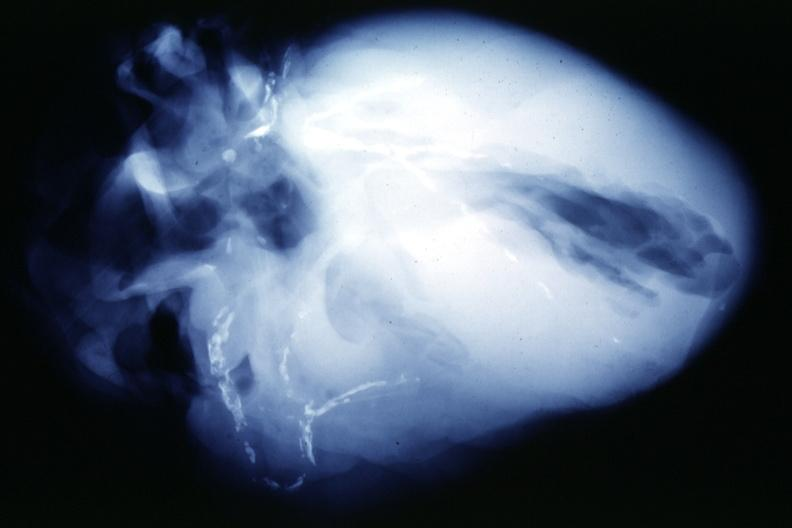s peritoneum present?
Answer the question using a single word or phrase. No 